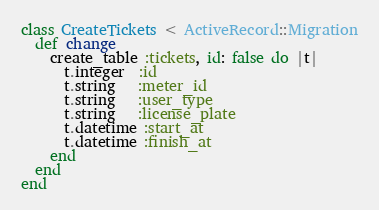Convert code to text. <code><loc_0><loc_0><loc_500><loc_500><_Ruby_>class CreateTickets < ActiveRecord::Migration
  def change
    create_table :tickets, id: false do |t|
      t.integer  :id
      t.string   :meter_id
      t.string   :user_type
      t.string   :license_plate
      t.datetime :start_at
      t.datetime :finish_at
    end
  end
end
</code> 